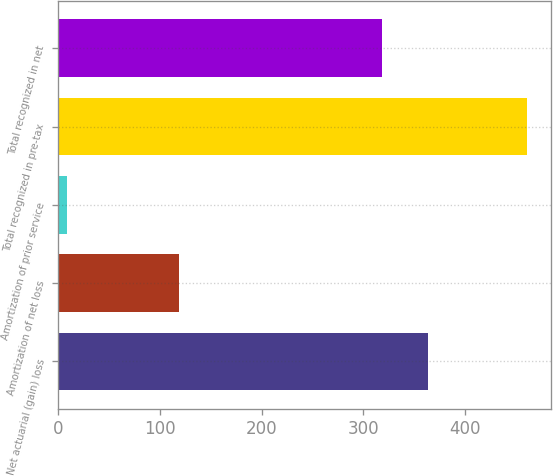<chart> <loc_0><loc_0><loc_500><loc_500><bar_chart><fcel>Net actuarial (gain) loss<fcel>Amortization of net loss<fcel>Amortization of prior service<fcel>Total recognized in pre-tax<fcel>Total recognized in net<nl><fcel>363.48<fcel>118.5<fcel>8.7<fcel>461.5<fcel>318.2<nl></chart> 